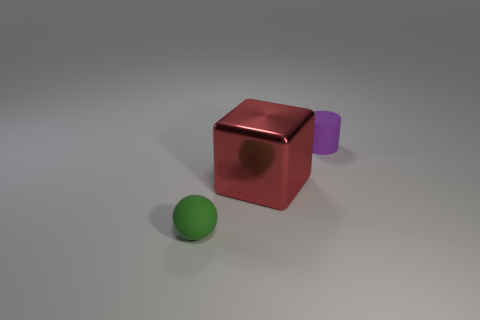Are there an equal number of tiny purple cylinders that are in front of the tiny matte cylinder and tiny green balls that are on the right side of the small green rubber object?
Your response must be concise. Yes. Is there anything else that is the same material as the green ball?
Your answer should be compact. Yes. There is a purple matte object; is its size the same as the matte object to the left of the red thing?
Keep it short and to the point. Yes. The small object to the left of the thing that is behind the metallic object is made of what material?
Give a very brief answer. Rubber. Are there the same number of small cylinders behind the purple cylinder and brown shiny objects?
Offer a terse response. Yes. What size is the thing that is left of the purple rubber object and behind the small ball?
Offer a terse response. Large. There is a cylinder to the right of the red metallic thing in front of the matte cylinder; what color is it?
Provide a short and direct response. Purple. What number of green objects are either small rubber things or small rubber cylinders?
Make the answer very short. 1. There is a object that is both in front of the small purple cylinder and right of the green rubber sphere; what is its color?
Offer a very short reply. Red. How many small things are either red shiny blocks or cylinders?
Your answer should be compact. 1. 